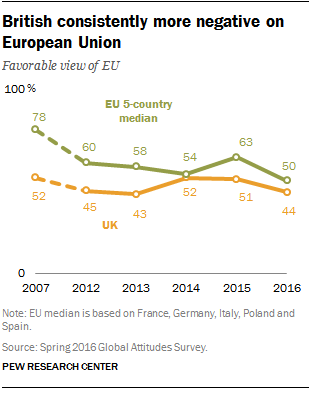Highlight a few significant elements in this photo. The green line in the graph represents the five-country median, which is an important indicator of economic performance in the European Union. The gap between the median household income in the UK and the EU reached its largest level in 2007. 